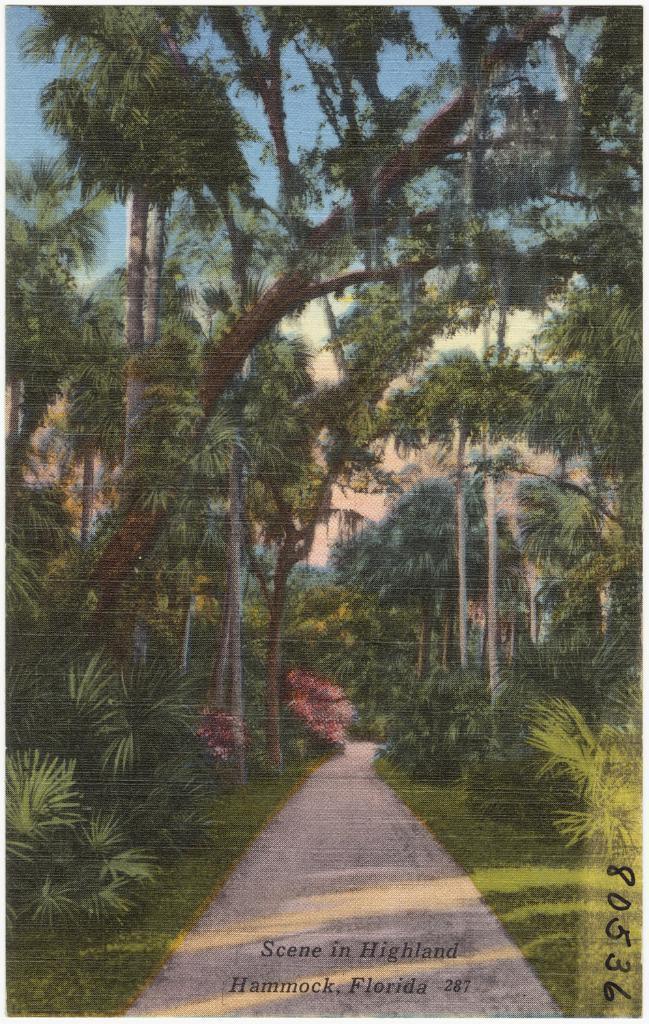How would you summarize this image in a sentence or two? In this picture I can see group of trees and grass and the sky visible ,at the bottom I can see the road. and text. 